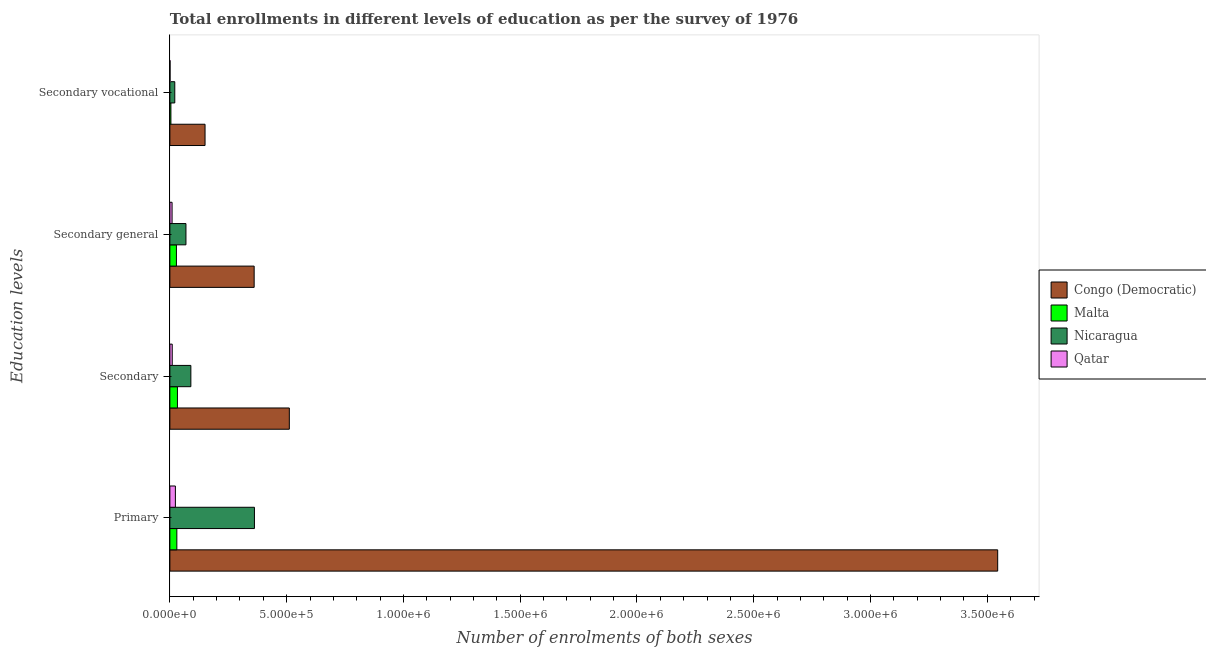How many groups of bars are there?
Offer a terse response. 4. Are the number of bars per tick equal to the number of legend labels?
Your answer should be very brief. Yes. What is the label of the 3rd group of bars from the top?
Give a very brief answer. Secondary. What is the number of enrolments in secondary vocational education in Congo (Democratic)?
Keep it short and to the point. 1.51e+05. Across all countries, what is the maximum number of enrolments in primary education?
Ensure brevity in your answer.  3.54e+06. Across all countries, what is the minimum number of enrolments in secondary general education?
Ensure brevity in your answer.  9416. In which country was the number of enrolments in secondary vocational education maximum?
Offer a very short reply. Congo (Democratic). In which country was the number of enrolments in primary education minimum?
Ensure brevity in your answer.  Qatar. What is the total number of enrolments in primary education in the graph?
Keep it short and to the point. 3.96e+06. What is the difference between the number of enrolments in secondary general education in Malta and that in Congo (Democratic)?
Make the answer very short. -3.33e+05. What is the difference between the number of enrolments in secondary vocational education in Congo (Democratic) and the number of enrolments in primary education in Malta?
Offer a very short reply. 1.21e+05. What is the average number of enrolments in secondary general education per country?
Your answer should be very brief. 1.17e+05. What is the difference between the number of enrolments in primary education and number of enrolments in secondary education in Congo (Democratic)?
Keep it short and to the point. 3.03e+06. In how many countries, is the number of enrolments in primary education greater than 2700000 ?
Provide a succinct answer. 1. What is the ratio of the number of enrolments in secondary education in Nicaragua to that in Malta?
Your answer should be compact. 2.77. Is the difference between the number of enrolments in primary education in Malta and Congo (Democratic) greater than the difference between the number of enrolments in secondary education in Malta and Congo (Democratic)?
Offer a very short reply. No. What is the difference between the highest and the second highest number of enrolments in secondary vocational education?
Give a very brief answer. 1.30e+05. What is the difference between the highest and the lowest number of enrolments in secondary vocational education?
Ensure brevity in your answer.  1.50e+05. In how many countries, is the number of enrolments in secondary education greater than the average number of enrolments in secondary education taken over all countries?
Your answer should be very brief. 1. What does the 1st bar from the top in Secondary vocational represents?
Keep it short and to the point. Qatar. What does the 4th bar from the bottom in Primary represents?
Offer a terse response. Qatar. Is it the case that in every country, the sum of the number of enrolments in primary education and number of enrolments in secondary education is greater than the number of enrolments in secondary general education?
Keep it short and to the point. Yes. How many bars are there?
Your answer should be very brief. 16. Are all the bars in the graph horizontal?
Provide a short and direct response. Yes. How many countries are there in the graph?
Your answer should be very brief. 4. Are the values on the major ticks of X-axis written in scientific E-notation?
Offer a terse response. Yes. Does the graph contain any zero values?
Ensure brevity in your answer.  No. Where does the legend appear in the graph?
Keep it short and to the point. Center right. What is the title of the graph?
Offer a very short reply. Total enrollments in different levels of education as per the survey of 1976. Does "Antigua and Barbuda" appear as one of the legend labels in the graph?
Offer a terse response. No. What is the label or title of the X-axis?
Keep it short and to the point. Number of enrolments of both sexes. What is the label or title of the Y-axis?
Provide a short and direct response. Education levels. What is the Number of enrolments of both sexes of Congo (Democratic) in Primary?
Offer a very short reply. 3.54e+06. What is the Number of enrolments of both sexes of Malta in Primary?
Your response must be concise. 2.98e+04. What is the Number of enrolments of both sexes of Nicaragua in Primary?
Your response must be concise. 3.62e+05. What is the Number of enrolments of both sexes in Qatar in Primary?
Make the answer very short. 2.36e+04. What is the Number of enrolments of both sexes in Congo (Democratic) in Secondary?
Give a very brief answer. 5.11e+05. What is the Number of enrolments of both sexes in Malta in Secondary?
Provide a short and direct response. 3.24e+04. What is the Number of enrolments of both sexes of Nicaragua in Secondary?
Make the answer very short. 8.98e+04. What is the Number of enrolments of both sexes in Qatar in Secondary?
Offer a terse response. 1.01e+04. What is the Number of enrolments of both sexes in Congo (Democratic) in Secondary general?
Give a very brief answer. 3.61e+05. What is the Number of enrolments of both sexes of Malta in Secondary general?
Give a very brief answer. 2.80e+04. What is the Number of enrolments of both sexes in Nicaragua in Secondary general?
Ensure brevity in your answer.  6.88e+04. What is the Number of enrolments of both sexes of Qatar in Secondary general?
Ensure brevity in your answer.  9416. What is the Number of enrolments of both sexes of Congo (Democratic) in Secondary vocational?
Provide a succinct answer. 1.51e+05. What is the Number of enrolments of both sexes of Malta in Secondary vocational?
Your answer should be very brief. 4387. What is the Number of enrolments of both sexes of Nicaragua in Secondary vocational?
Ensure brevity in your answer.  2.10e+04. What is the Number of enrolments of both sexes in Qatar in Secondary vocational?
Make the answer very short. 693. Across all Education levels, what is the maximum Number of enrolments of both sexes in Congo (Democratic)?
Your response must be concise. 3.54e+06. Across all Education levels, what is the maximum Number of enrolments of both sexes of Malta?
Provide a succinct answer. 3.24e+04. Across all Education levels, what is the maximum Number of enrolments of both sexes of Nicaragua?
Give a very brief answer. 3.62e+05. Across all Education levels, what is the maximum Number of enrolments of both sexes in Qatar?
Your answer should be very brief. 2.36e+04. Across all Education levels, what is the minimum Number of enrolments of both sexes in Congo (Democratic)?
Offer a terse response. 1.51e+05. Across all Education levels, what is the minimum Number of enrolments of both sexes of Malta?
Provide a short and direct response. 4387. Across all Education levels, what is the minimum Number of enrolments of both sexes of Nicaragua?
Keep it short and to the point. 2.10e+04. Across all Education levels, what is the minimum Number of enrolments of both sexes of Qatar?
Give a very brief answer. 693. What is the total Number of enrolments of both sexes of Congo (Democratic) in the graph?
Offer a terse response. 4.57e+06. What is the total Number of enrolments of both sexes of Malta in the graph?
Your answer should be compact. 9.47e+04. What is the total Number of enrolments of both sexes of Nicaragua in the graph?
Provide a short and direct response. 5.42e+05. What is the total Number of enrolments of both sexes of Qatar in the graph?
Provide a succinct answer. 4.38e+04. What is the difference between the Number of enrolments of both sexes of Congo (Democratic) in Primary and that in Secondary?
Your answer should be compact. 3.03e+06. What is the difference between the Number of enrolments of both sexes of Malta in Primary and that in Secondary?
Your response must be concise. -2575. What is the difference between the Number of enrolments of both sexes of Nicaragua in Primary and that in Secondary?
Provide a short and direct response. 2.72e+05. What is the difference between the Number of enrolments of both sexes of Qatar in Primary and that in Secondary?
Your response must be concise. 1.35e+04. What is the difference between the Number of enrolments of both sexes in Congo (Democratic) in Primary and that in Secondary general?
Your response must be concise. 3.18e+06. What is the difference between the Number of enrolments of both sexes of Malta in Primary and that in Secondary general?
Make the answer very short. 1812. What is the difference between the Number of enrolments of both sexes in Nicaragua in Primary and that in Secondary general?
Keep it short and to the point. 2.93e+05. What is the difference between the Number of enrolments of both sexes in Qatar in Primary and that in Secondary general?
Give a very brief answer. 1.42e+04. What is the difference between the Number of enrolments of both sexes in Congo (Democratic) in Primary and that in Secondary vocational?
Your answer should be compact. 3.39e+06. What is the difference between the Number of enrolments of both sexes in Malta in Primary and that in Secondary vocational?
Offer a very short reply. 2.54e+04. What is the difference between the Number of enrolments of both sexes in Nicaragua in Primary and that in Secondary vocational?
Give a very brief answer. 3.41e+05. What is the difference between the Number of enrolments of both sexes in Qatar in Primary and that in Secondary vocational?
Offer a very short reply. 2.29e+04. What is the difference between the Number of enrolments of both sexes in Congo (Democratic) in Secondary and that in Secondary general?
Give a very brief answer. 1.51e+05. What is the difference between the Number of enrolments of both sexes in Malta in Secondary and that in Secondary general?
Keep it short and to the point. 4387. What is the difference between the Number of enrolments of both sexes in Nicaragua in Secondary and that in Secondary general?
Your answer should be very brief. 2.10e+04. What is the difference between the Number of enrolments of both sexes in Qatar in Secondary and that in Secondary general?
Keep it short and to the point. 693. What is the difference between the Number of enrolments of both sexes of Congo (Democratic) in Secondary and that in Secondary vocational?
Provide a short and direct response. 3.61e+05. What is the difference between the Number of enrolments of both sexes in Malta in Secondary and that in Secondary vocational?
Your answer should be very brief. 2.80e+04. What is the difference between the Number of enrolments of both sexes in Nicaragua in Secondary and that in Secondary vocational?
Provide a succinct answer. 6.88e+04. What is the difference between the Number of enrolments of both sexes in Qatar in Secondary and that in Secondary vocational?
Keep it short and to the point. 9416. What is the difference between the Number of enrolments of both sexes in Congo (Democratic) in Secondary general and that in Secondary vocational?
Offer a terse response. 2.10e+05. What is the difference between the Number of enrolments of both sexes in Malta in Secondary general and that in Secondary vocational?
Your response must be concise. 2.36e+04. What is the difference between the Number of enrolments of both sexes in Nicaragua in Secondary general and that in Secondary vocational?
Your answer should be very brief. 4.78e+04. What is the difference between the Number of enrolments of both sexes in Qatar in Secondary general and that in Secondary vocational?
Keep it short and to the point. 8723. What is the difference between the Number of enrolments of both sexes of Congo (Democratic) in Primary and the Number of enrolments of both sexes of Malta in Secondary?
Your response must be concise. 3.51e+06. What is the difference between the Number of enrolments of both sexes in Congo (Democratic) in Primary and the Number of enrolments of both sexes in Nicaragua in Secondary?
Provide a short and direct response. 3.45e+06. What is the difference between the Number of enrolments of both sexes of Congo (Democratic) in Primary and the Number of enrolments of both sexes of Qatar in Secondary?
Give a very brief answer. 3.53e+06. What is the difference between the Number of enrolments of both sexes of Malta in Primary and the Number of enrolments of both sexes of Nicaragua in Secondary?
Your response must be concise. -6.00e+04. What is the difference between the Number of enrolments of both sexes of Malta in Primary and the Number of enrolments of both sexes of Qatar in Secondary?
Your response must be concise. 1.97e+04. What is the difference between the Number of enrolments of both sexes in Nicaragua in Primary and the Number of enrolments of both sexes in Qatar in Secondary?
Ensure brevity in your answer.  3.52e+05. What is the difference between the Number of enrolments of both sexes of Congo (Democratic) in Primary and the Number of enrolments of both sexes of Malta in Secondary general?
Your answer should be very brief. 3.52e+06. What is the difference between the Number of enrolments of both sexes of Congo (Democratic) in Primary and the Number of enrolments of both sexes of Nicaragua in Secondary general?
Your response must be concise. 3.48e+06. What is the difference between the Number of enrolments of both sexes in Congo (Democratic) in Primary and the Number of enrolments of both sexes in Qatar in Secondary general?
Offer a terse response. 3.54e+06. What is the difference between the Number of enrolments of both sexes in Malta in Primary and the Number of enrolments of both sexes in Nicaragua in Secondary general?
Offer a terse response. -3.90e+04. What is the difference between the Number of enrolments of both sexes in Malta in Primary and the Number of enrolments of both sexes in Qatar in Secondary general?
Give a very brief answer. 2.04e+04. What is the difference between the Number of enrolments of both sexes of Nicaragua in Primary and the Number of enrolments of both sexes of Qatar in Secondary general?
Provide a succinct answer. 3.53e+05. What is the difference between the Number of enrolments of both sexes of Congo (Democratic) in Primary and the Number of enrolments of both sexes of Malta in Secondary vocational?
Provide a succinct answer. 3.54e+06. What is the difference between the Number of enrolments of both sexes in Congo (Democratic) in Primary and the Number of enrolments of both sexes in Nicaragua in Secondary vocational?
Offer a terse response. 3.52e+06. What is the difference between the Number of enrolments of both sexes in Congo (Democratic) in Primary and the Number of enrolments of both sexes in Qatar in Secondary vocational?
Provide a short and direct response. 3.54e+06. What is the difference between the Number of enrolments of both sexes in Malta in Primary and the Number of enrolments of both sexes in Nicaragua in Secondary vocational?
Offer a terse response. 8839. What is the difference between the Number of enrolments of both sexes of Malta in Primary and the Number of enrolments of both sexes of Qatar in Secondary vocational?
Your response must be concise. 2.91e+04. What is the difference between the Number of enrolments of both sexes in Nicaragua in Primary and the Number of enrolments of both sexes in Qatar in Secondary vocational?
Provide a short and direct response. 3.61e+05. What is the difference between the Number of enrolments of both sexes of Congo (Democratic) in Secondary and the Number of enrolments of both sexes of Malta in Secondary general?
Provide a short and direct response. 4.83e+05. What is the difference between the Number of enrolments of both sexes of Congo (Democratic) in Secondary and the Number of enrolments of both sexes of Nicaragua in Secondary general?
Your response must be concise. 4.43e+05. What is the difference between the Number of enrolments of both sexes of Congo (Democratic) in Secondary and the Number of enrolments of both sexes of Qatar in Secondary general?
Give a very brief answer. 5.02e+05. What is the difference between the Number of enrolments of both sexes in Malta in Secondary and the Number of enrolments of both sexes in Nicaragua in Secondary general?
Your answer should be very brief. -3.64e+04. What is the difference between the Number of enrolments of both sexes in Malta in Secondary and the Number of enrolments of both sexes in Qatar in Secondary general?
Make the answer very short. 2.30e+04. What is the difference between the Number of enrolments of both sexes in Nicaragua in Secondary and the Number of enrolments of both sexes in Qatar in Secondary general?
Provide a succinct answer. 8.04e+04. What is the difference between the Number of enrolments of both sexes of Congo (Democratic) in Secondary and the Number of enrolments of both sexes of Malta in Secondary vocational?
Your answer should be very brief. 5.07e+05. What is the difference between the Number of enrolments of both sexes of Congo (Democratic) in Secondary and the Number of enrolments of both sexes of Nicaragua in Secondary vocational?
Provide a short and direct response. 4.90e+05. What is the difference between the Number of enrolments of both sexes in Congo (Democratic) in Secondary and the Number of enrolments of both sexes in Qatar in Secondary vocational?
Your answer should be compact. 5.11e+05. What is the difference between the Number of enrolments of both sexes in Malta in Secondary and the Number of enrolments of both sexes in Nicaragua in Secondary vocational?
Give a very brief answer. 1.14e+04. What is the difference between the Number of enrolments of both sexes of Malta in Secondary and the Number of enrolments of both sexes of Qatar in Secondary vocational?
Your response must be concise. 3.17e+04. What is the difference between the Number of enrolments of both sexes of Nicaragua in Secondary and the Number of enrolments of both sexes of Qatar in Secondary vocational?
Provide a succinct answer. 8.91e+04. What is the difference between the Number of enrolments of both sexes of Congo (Democratic) in Secondary general and the Number of enrolments of both sexes of Malta in Secondary vocational?
Offer a very short reply. 3.57e+05. What is the difference between the Number of enrolments of both sexes in Congo (Democratic) in Secondary general and the Number of enrolments of both sexes in Nicaragua in Secondary vocational?
Your answer should be compact. 3.40e+05. What is the difference between the Number of enrolments of both sexes of Congo (Democratic) in Secondary general and the Number of enrolments of both sexes of Qatar in Secondary vocational?
Your answer should be compact. 3.60e+05. What is the difference between the Number of enrolments of both sexes in Malta in Secondary general and the Number of enrolments of both sexes in Nicaragua in Secondary vocational?
Your answer should be very brief. 7027. What is the difference between the Number of enrolments of both sexes of Malta in Secondary general and the Number of enrolments of both sexes of Qatar in Secondary vocational?
Give a very brief answer. 2.73e+04. What is the difference between the Number of enrolments of both sexes of Nicaragua in Secondary general and the Number of enrolments of both sexes of Qatar in Secondary vocational?
Your response must be concise. 6.81e+04. What is the average Number of enrolments of both sexes in Congo (Democratic) per Education levels?
Offer a very short reply. 1.14e+06. What is the average Number of enrolments of both sexes in Malta per Education levels?
Keep it short and to the point. 2.37e+04. What is the average Number of enrolments of both sexes of Nicaragua per Education levels?
Your answer should be very brief. 1.35e+05. What is the average Number of enrolments of both sexes in Qatar per Education levels?
Provide a succinct answer. 1.10e+04. What is the difference between the Number of enrolments of both sexes in Congo (Democratic) and Number of enrolments of both sexes in Malta in Primary?
Provide a short and direct response. 3.51e+06. What is the difference between the Number of enrolments of both sexes of Congo (Democratic) and Number of enrolments of both sexes of Nicaragua in Primary?
Ensure brevity in your answer.  3.18e+06. What is the difference between the Number of enrolments of both sexes of Congo (Democratic) and Number of enrolments of both sexes of Qatar in Primary?
Provide a succinct answer. 3.52e+06. What is the difference between the Number of enrolments of both sexes in Malta and Number of enrolments of both sexes in Nicaragua in Primary?
Offer a terse response. -3.32e+05. What is the difference between the Number of enrolments of both sexes in Malta and Number of enrolments of both sexes in Qatar in Primary?
Your answer should be very brief. 6219. What is the difference between the Number of enrolments of both sexes of Nicaragua and Number of enrolments of both sexes of Qatar in Primary?
Your answer should be compact. 3.38e+05. What is the difference between the Number of enrolments of both sexes of Congo (Democratic) and Number of enrolments of both sexes of Malta in Secondary?
Ensure brevity in your answer.  4.79e+05. What is the difference between the Number of enrolments of both sexes of Congo (Democratic) and Number of enrolments of both sexes of Nicaragua in Secondary?
Offer a terse response. 4.22e+05. What is the difference between the Number of enrolments of both sexes of Congo (Democratic) and Number of enrolments of both sexes of Qatar in Secondary?
Offer a terse response. 5.01e+05. What is the difference between the Number of enrolments of both sexes of Malta and Number of enrolments of both sexes of Nicaragua in Secondary?
Your answer should be very brief. -5.74e+04. What is the difference between the Number of enrolments of both sexes in Malta and Number of enrolments of both sexes in Qatar in Secondary?
Offer a terse response. 2.23e+04. What is the difference between the Number of enrolments of both sexes of Nicaragua and Number of enrolments of both sexes of Qatar in Secondary?
Offer a terse response. 7.97e+04. What is the difference between the Number of enrolments of both sexes in Congo (Democratic) and Number of enrolments of both sexes in Malta in Secondary general?
Keep it short and to the point. 3.33e+05. What is the difference between the Number of enrolments of both sexes of Congo (Democratic) and Number of enrolments of both sexes of Nicaragua in Secondary general?
Make the answer very short. 2.92e+05. What is the difference between the Number of enrolments of both sexes in Congo (Democratic) and Number of enrolments of both sexes in Qatar in Secondary general?
Offer a very short reply. 3.51e+05. What is the difference between the Number of enrolments of both sexes of Malta and Number of enrolments of both sexes of Nicaragua in Secondary general?
Keep it short and to the point. -4.08e+04. What is the difference between the Number of enrolments of both sexes of Malta and Number of enrolments of both sexes of Qatar in Secondary general?
Provide a short and direct response. 1.86e+04. What is the difference between the Number of enrolments of both sexes in Nicaragua and Number of enrolments of both sexes in Qatar in Secondary general?
Ensure brevity in your answer.  5.94e+04. What is the difference between the Number of enrolments of both sexes in Congo (Democratic) and Number of enrolments of both sexes in Malta in Secondary vocational?
Keep it short and to the point. 1.46e+05. What is the difference between the Number of enrolments of both sexes of Congo (Democratic) and Number of enrolments of both sexes of Nicaragua in Secondary vocational?
Offer a very short reply. 1.30e+05. What is the difference between the Number of enrolments of both sexes in Congo (Democratic) and Number of enrolments of both sexes in Qatar in Secondary vocational?
Your answer should be very brief. 1.50e+05. What is the difference between the Number of enrolments of both sexes of Malta and Number of enrolments of both sexes of Nicaragua in Secondary vocational?
Your answer should be compact. -1.66e+04. What is the difference between the Number of enrolments of both sexes in Malta and Number of enrolments of both sexes in Qatar in Secondary vocational?
Your answer should be very brief. 3694. What is the difference between the Number of enrolments of both sexes of Nicaragua and Number of enrolments of both sexes of Qatar in Secondary vocational?
Your response must be concise. 2.03e+04. What is the ratio of the Number of enrolments of both sexes of Congo (Democratic) in Primary to that in Secondary?
Give a very brief answer. 6.93. What is the ratio of the Number of enrolments of both sexes in Malta in Primary to that in Secondary?
Your answer should be very brief. 0.92. What is the ratio of the Number of enrolments of both sexes in Nicaragua in Primary to that in Secondary?
Your response must be concise. 4.03. What is the ratio of the Number of enrolments of both sexes of Qatar in Primary to that in Secondary?
Offer a very short reply. 2.34. What is the ratio of the Number of enrolments of both sexes in Congo (Democratic) in Primary to that in Secondary general?
Offer a terse response. 9.82. What is the ratio of the Number of enrolments of both sexes in Malta in Primary to that in Secondary general?
Make the answer very short. 1.06. What is the ratio of the Number of enrolments of both sexes of Nicaragua in Primary to that in Secondary general?
Your answer should be compact. 5.26. What is the ratio of the Number of enrolments of both sexes of Qatar in Primary to that in Secondary general?
Your answer should be very brief. 2.51. What is the ratio of the Number of enrolments of both sexes in Congo (Democratic) in Primary to that in Secondary vocational?
Make the answer very short. 23.54. What is the ratio of the Number of enrolments of both sexes in Malta in Primary to that in Secondary vocational?
Provide a succinct answer. 6.8. What is the ratio of the Number of enrolments of both sexes of Nicaragua in Primary to that in Secondary vocational?
Ensure brevity in your answer.  17.25. What is the ratio of the Number of enrolments of both sexes in Qatar in Primary to that in Secondary vocational?
Offer a terse response. 34.08. What is the ratio of the Number of enrolments of both sexes in Congo (Democratic) in Secondary to that in Secondary general?
Offer a very short reply. 1.42. What is the ratio of the Number of enrolments of both sexes of Malta in Secondary to that in Secondary general?
Give a very brief answer. 1.16. What is the ratio of the Number of enrolments of both sexes of Nicaragua in Secondary to that in Secondary general?
Give a very brief answer. 1.3. What is the ratio of the Number of enrolments of both sexes in Qatar in Secondary to that in Secondary general?
Offer a very short reply. 1.07. What is the ratio of the Number of enrolments of both sexes in Congo (Democratic) in Secondary to that in Secondary vocational?
Your answer should be very brief. 3.4. What is the ratio of the Number of enrolments of both sexes of Malta in Secondary to that in Secondary vocational?
Keep it short and to the point. 7.39. What is the ratio of the Number of enrolments of both sexes of Nicaragua in Secondary to that in Secondary vocational?
Offer a terse response. 4.28. What is the ratio of the Number of enrolments of both sexes in Qatar in Secondary to that in Secondary vocational?
Provide a short and direct response. 14.59. What is the ratio of the Number of enrolments of both sexes of Congo (Democratic) in Secondary general to that in Secondary vocational?
Make the answer very short. 2.4. What is the ratio of the Number of enrolments of both sexes of Malta in Secondary general to that in Secondary vocational?
Keep it short and to the point. 6.39. What is the ratio of the Number of enrolments of both sexes of Nicaragua in Secondary general to that in Secondary vocational?
Ensure brevity in your answer.  3.28. What is the ratio of the Number of enrolments of both sexes in Qatar in Secondary general to that in Secondary vocational?
Ensure brevity in your answer.  13.59. What is the difference between the highest and the second highest Number of enrolments of both sexes of Congo (Democratic)?
Ensure brevity in your answer.  3.03e+06. What is the difference between the highest and the second highest Number of enrolments of both sexes of Malta?
Your answer should be compact. 2575. What is the difference between the highest and the second highest Number of enrolments of both sexes in Nicaragua?
Keep it short and to the point. 2.72e+05. What is the difference between the highest and the second highest Number of enrolments of both sexes of Qatar?
Your response must be concise. 1.35e+04. What is the difference between the highest and the lowest Number of enrolments of both sexes of Congo (Democratic)?
Offer a terse response. 3.39e+06. What is the difference between the highest and the lowest Number of enrolments of both sexes of Malta?
Provide a succinct answer. 2.80e+04. What is the difference between the highest and the lowest Number of enrolments of both sexes in Nicaragua?
Ensure brevity in your answer.  3.41e+05. What is the difference between the highest and the lowest Number of enrolments of both sexes of Qatar?
Ensure brevity in your answer.  2.29e+04. 